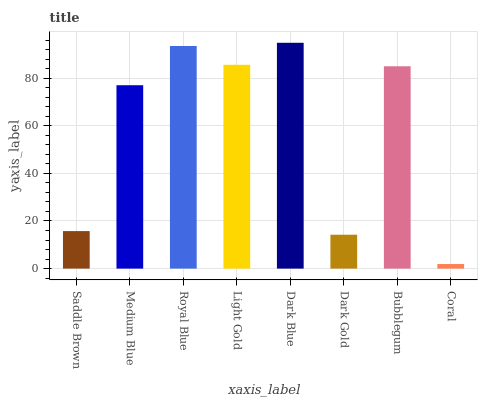Is Coral the minimum?
Answer yes or no. Yes. Is Dark Blue the maximum?
Answer yes or no. Yes. Is Medium Blue the minimum?
Answer yes or no. No. Is Medium Blue the maximum?
Answer yes or no. No. Is Medium Blue greater than Saddle Brown?
Answer yes or no. Yes. Is Saddle Brown less than Medium Blue?
Answer yes or no. Yes. Is Saddle Brown greater than Medium Blue?
Answer yes or no. No. Is Medium Blue less than Saddle Brown?
Answer yes or no. No. Is Bubblegum the high median?
Answer yes or no. Yes. Is Medium Blue the low median?
Answer yes or no. Yes. Is Dark Blue the high median?
Answer yes or no. No. Is Coral the low median?
Answer yes or no. No. 